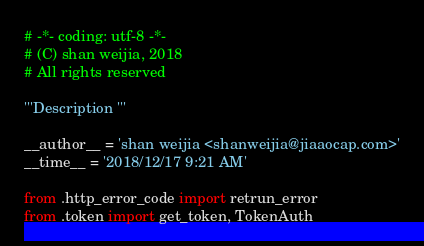<code> <loc_0><loc_0><loc_500><loc_500><_Python_># -*- coding: utf-8 -*-
# (C) shan weijia, 2018
# All rights reserved

'''Description '''

__author__ = 'shan weijia <shanweijia@jiaaocap.com>'
__time__ = '2018/12/17 9:21 AM'

from .http_error_code import retrun_error
from .token import get_token, TokenAuth
</code> 